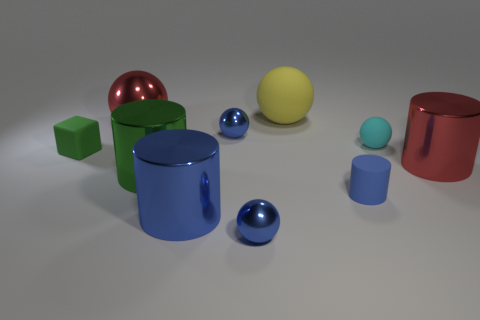What number of red metallic cylinders are on the right side of the big red shiny object on the left side of the cylinder behind the large green cylinder?
Give a very brief answer. 1. There is a small object that is both in front of the tiny cyan ball and on the right side of the large yellow thing; what is its material?
Provide a succinct answer. Rubber. The tiny matte sphere has what color?
Your response must be concise. Cyan. Is the number of blue metallic cylinders behind the green metallic cylinder greater than the number of blue cylinders to the left of the tiny matte cylinder?
Give a very brief answer. No. There is a tiny metallic object that is in front of the big green shiny object; what color is it?
Offer a terse response. Blue. There is a red shiny thing that is behind the tiny matte sphere; is its size the same as the cylinder that is to the right of the tiny matte cylinder?
Your answer should be compact. Yes. What number of things are large green matte objects or tiny green matte blocks?
Keep it short and to the point. 1. The red object that is on the right side of the big rubber thing that is to the right of the tiny cube is made of what material?
Your answer should be compact. Metal. How many small green things are the same shape as the big matte thing?
Keep it short and to the point. 0. Are there any big matte balls that have the same color as the tiny matte ball?
Give a very brief answer. No. 